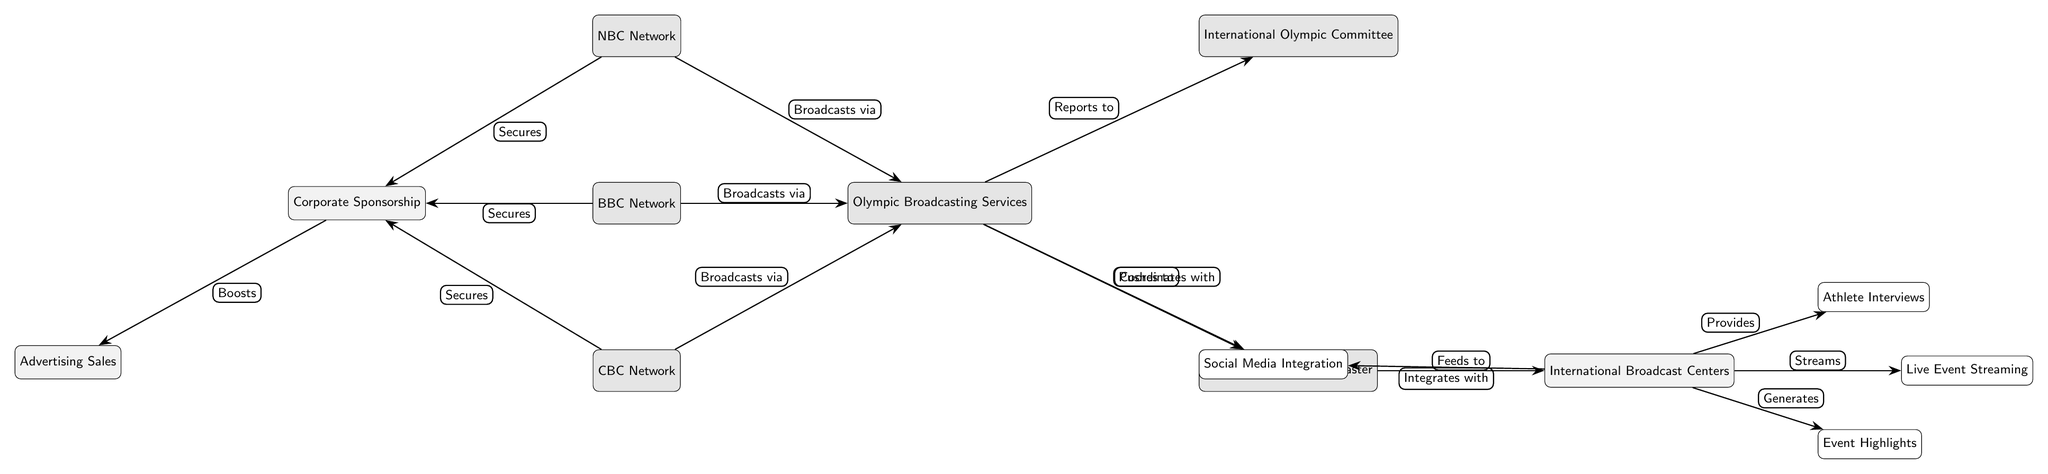What nodes broadcast via OBS? The nodes that broadcast via OBS are NBC Network, BBC Network, and CBC Network. By analyzing the edges leading from these nodes, we see they all connect to OBS with the label "Broadcasts via."
Answer: NBC Network, BBC Network, CBC Network How many nodes are in this diagram? To find the number of nodes, we simply count each unique node listed. There are 12 nodes: NBC Network, BBC Network, CBC Network, Olympic Broadcasting Services, International Olympic Committee, Tokyo 2020 Host Broadcaster, International Broadcast Centers, Athlete Interviews, Live Event Streaming, Event Highlights, Social Media Integration, and Corporate Sponsorship.
Answer: 12 What is the role of the JapanHost in this network? The JapanHost coordinates with Olympic Broadcasting Services and feeds to International Broadcast Centers. The edges show its direct connections to OBS and ConnectCities, indicating its role in assisting broadcast.
Answer: Coordinates with, Feeds to Which node generates Highlights? The node that generates Highlights is International Broadcast Centers. This is determined by following the edge labeled "Generates" from ConnectCities to Highlights.
Answer: International Broadcast Centers How many networks secure sponsorship? Three networks secure sponsorship: NBC Network, BBC Network, and CBC Network. This is evident from the edges leading to the Corporate Sponsorship node, indicating that all three have this connection.
Answer: 3 What does OBS push to? OBS pushes to Social Media. This relationship is shown on the edge connecting OBS to Social Media with the label "Pushes to."
Answer: Social Media Which node is responsible for advertising sales? The node responsible for advertising sales is Advertising Sales. It is connected by an edge labeled "Boosts" from Corporate Sponsorship, showing its role in the broadcasting network.
Answer: Advertising Sales How does Corporate Sponsorship affect Advertising Sales? Corporate Sponsorship boosts Advertising Sales, as indicated by the directed edge from Sponsorship to AdSales with the label "Boosts." This shows a direct influence in the network's financial processes.
Answer: Boosts 